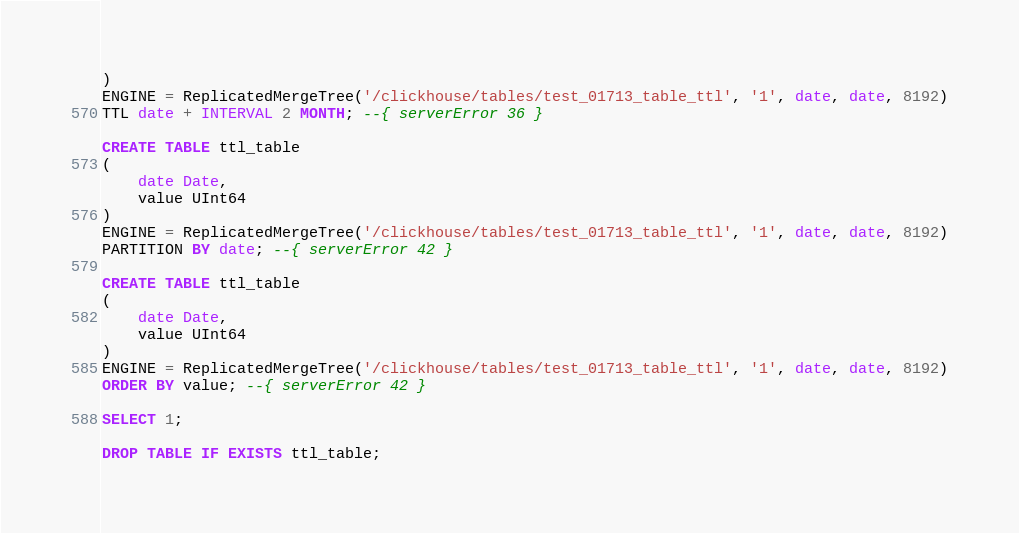Convert code to text. <code><loc_0><loc_0><loc_500><loc_500><_SQL_>)
ENGINE = ReplicatedMergeTree('/clickhouse/tables/test_01713_table_ttl', '1', date, date, 8192)
TTL date + INTERVAL 2 MONTH; --{ serverError 36 }

CREATE TABLE ttl_table
(
    date Date,
    value UInt64
)
ENGINE = ReplicatedMergeTree('/clickhouse/tables/test_01713_table_ttl', '1', date, date, 8192)
PARTITION BY date; --{ serverError 42 }

CREATE TABLE ttl_table
(
    date Date,
    value UInt64
)
ENGINE = ReplicatedMergeTree('/clickhouse/tables/test_01713_table_ttl', '1', date, date, 8192)
ORDER BY value; --{ serverError 42 }

SELECT 1;

DROP TABLE IF EXISTS ttl_table;
</code> 